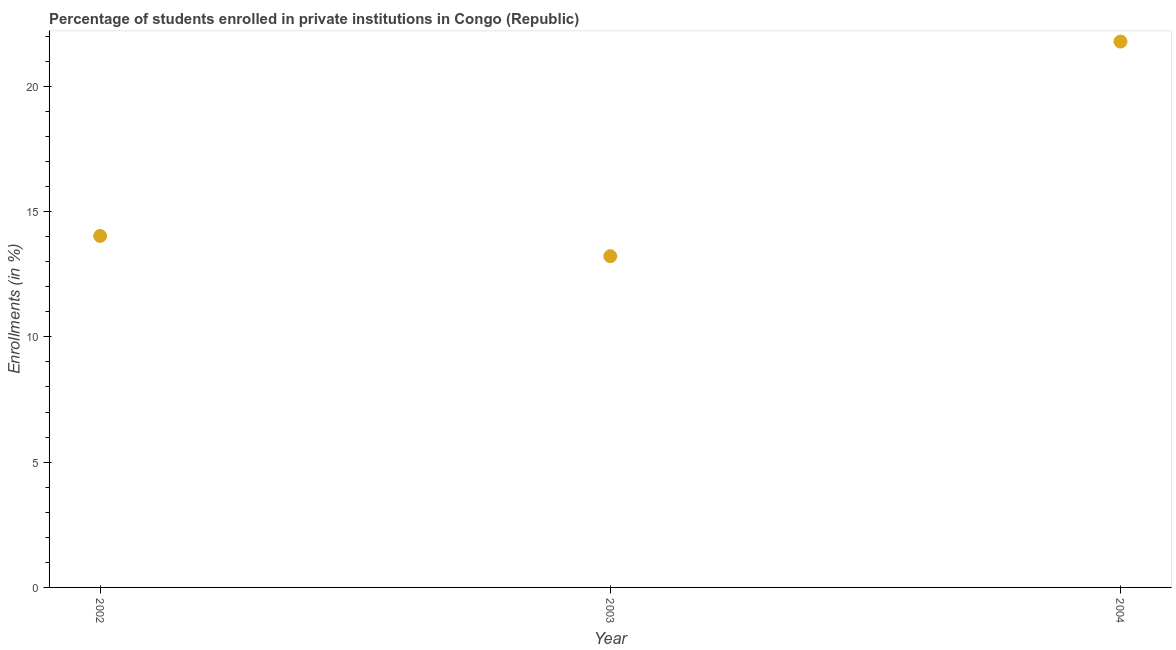What is the enrollments in private institutions in 2003?
Provide a succinct answer. 13.22. Across all years, what is the maximum enrollments in private institutions?
Keep it short and to the point. 21.79. Across all years, what is the minimum enrollments in private institutions?
Provide a succinct answer. 13.22. In which year was the enrollments in private institutions maximum?
Give a very brief answer. 2004. In which year was the enrollments in private institutions minimum?
Offer a very short reply. 2003. What is the sum of the enrollments in private institutions?
Your answer should be very brief. 49.03. What is the difference between the enrollments in private institutions in 2002 and 2003?
Your answer should be very brief. 0.81. What is the average enrollments in private institutions per year?
Provide a short and direct response. 16.34. What is the median enrollments in private institutions?
Keep it short and to the point. 14.03. In how many years, is the enrollments in private institutions greater than 20 %?
Offer a very short reply. 1. Do a majority of the years between 2004 and 2002 (inclusive) have enrollments in private institutions greater than 4 %?
Offer a very short reply. No. What is the ratio of the enrollments in private institutions in 2002 to that in 2004?
Offer a terse response. 0.64. Is the enrollments in private institutions in 2002 less than that in 2003?
Your response must be concise. No. Is the difference between the enrollments in private institutions in 2002 and 2003 greater than the difference between any two years?
Your response must be concise. No. What is the difference between the highest and the second highest enrollments in private institutions?
Offer a terse response. 7.76. Is the sum of the enrollments in private institutions in 2002 and 2003 greater than the maximum enrollments in private institutions across all years?
Offer a very short reply. Yes. What is the difference between the highest and the lowest enrollments in private institutions?
Offer a very short reply. 8.57. In how many years, is the enrollments in private institutions greater than the average enrollments in private institutions taken over all years?
Make the answer very short. 1. What is the title of the graph?
Keep it short and to the point. Percentage of students enrolled in private institutions in Congo (Republic). What is the label or title of the X-axis?
Make the answer very short. Year. What is the label or title of the Y-axis?
Ensure brevity in your answer.  Enrollments (in %). What is the Enrollments (in %) in 2002?
Give a very brief answer. 14.03. What is the Enrollments (in %) in 2003?
Offer a terse response. 13.22. What is the Enrollments (in %) in 2004?
Provide a short and direct response. 21.79. What is the difference between the Enrollments (in %) in 2002 and 2003?
Your response must be concise. 0.81. What is the difference between the Enrollments (in %) in 2002 and 2004?
Provide a succinct answer. -7.76. What is the difference between the Enrollments (in %) in 2003 and 2004?
Keep it short and to the point. -8.57. What is the ratio of the Enrollments (in %) in 2002 to that in 2003?
Ensure brevity in your answer.  1.06. What is the ratio of the Enrollments (in %) in 2002 to that in 2004?
Provide a succinct answer. 0.64. What is the ratio of the Enrollments (in %) in 2003 to that in 2004?
Give a very brief answer. 0.61. 